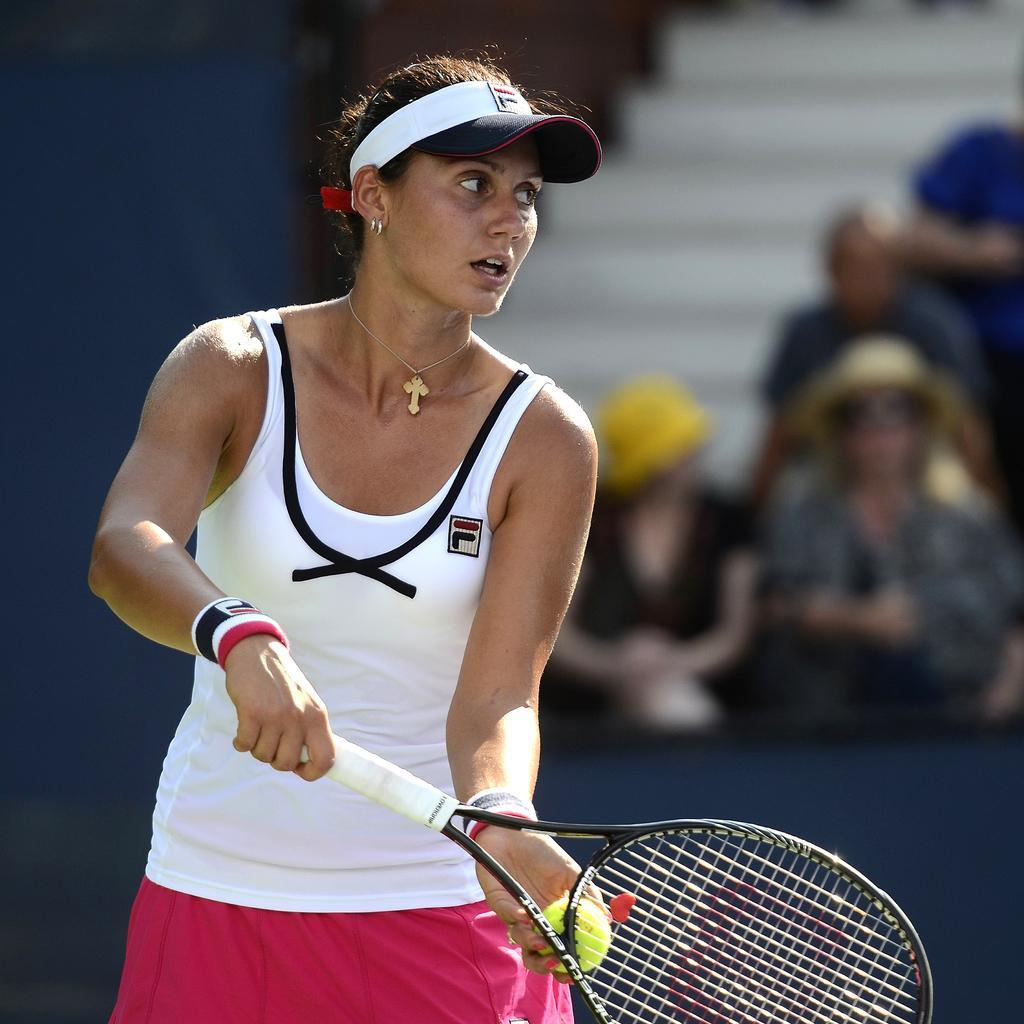How would you summarize this image in a sentence or two? In this image we can see a woman holding a racket and ball in her hands. In the background we can see people. 